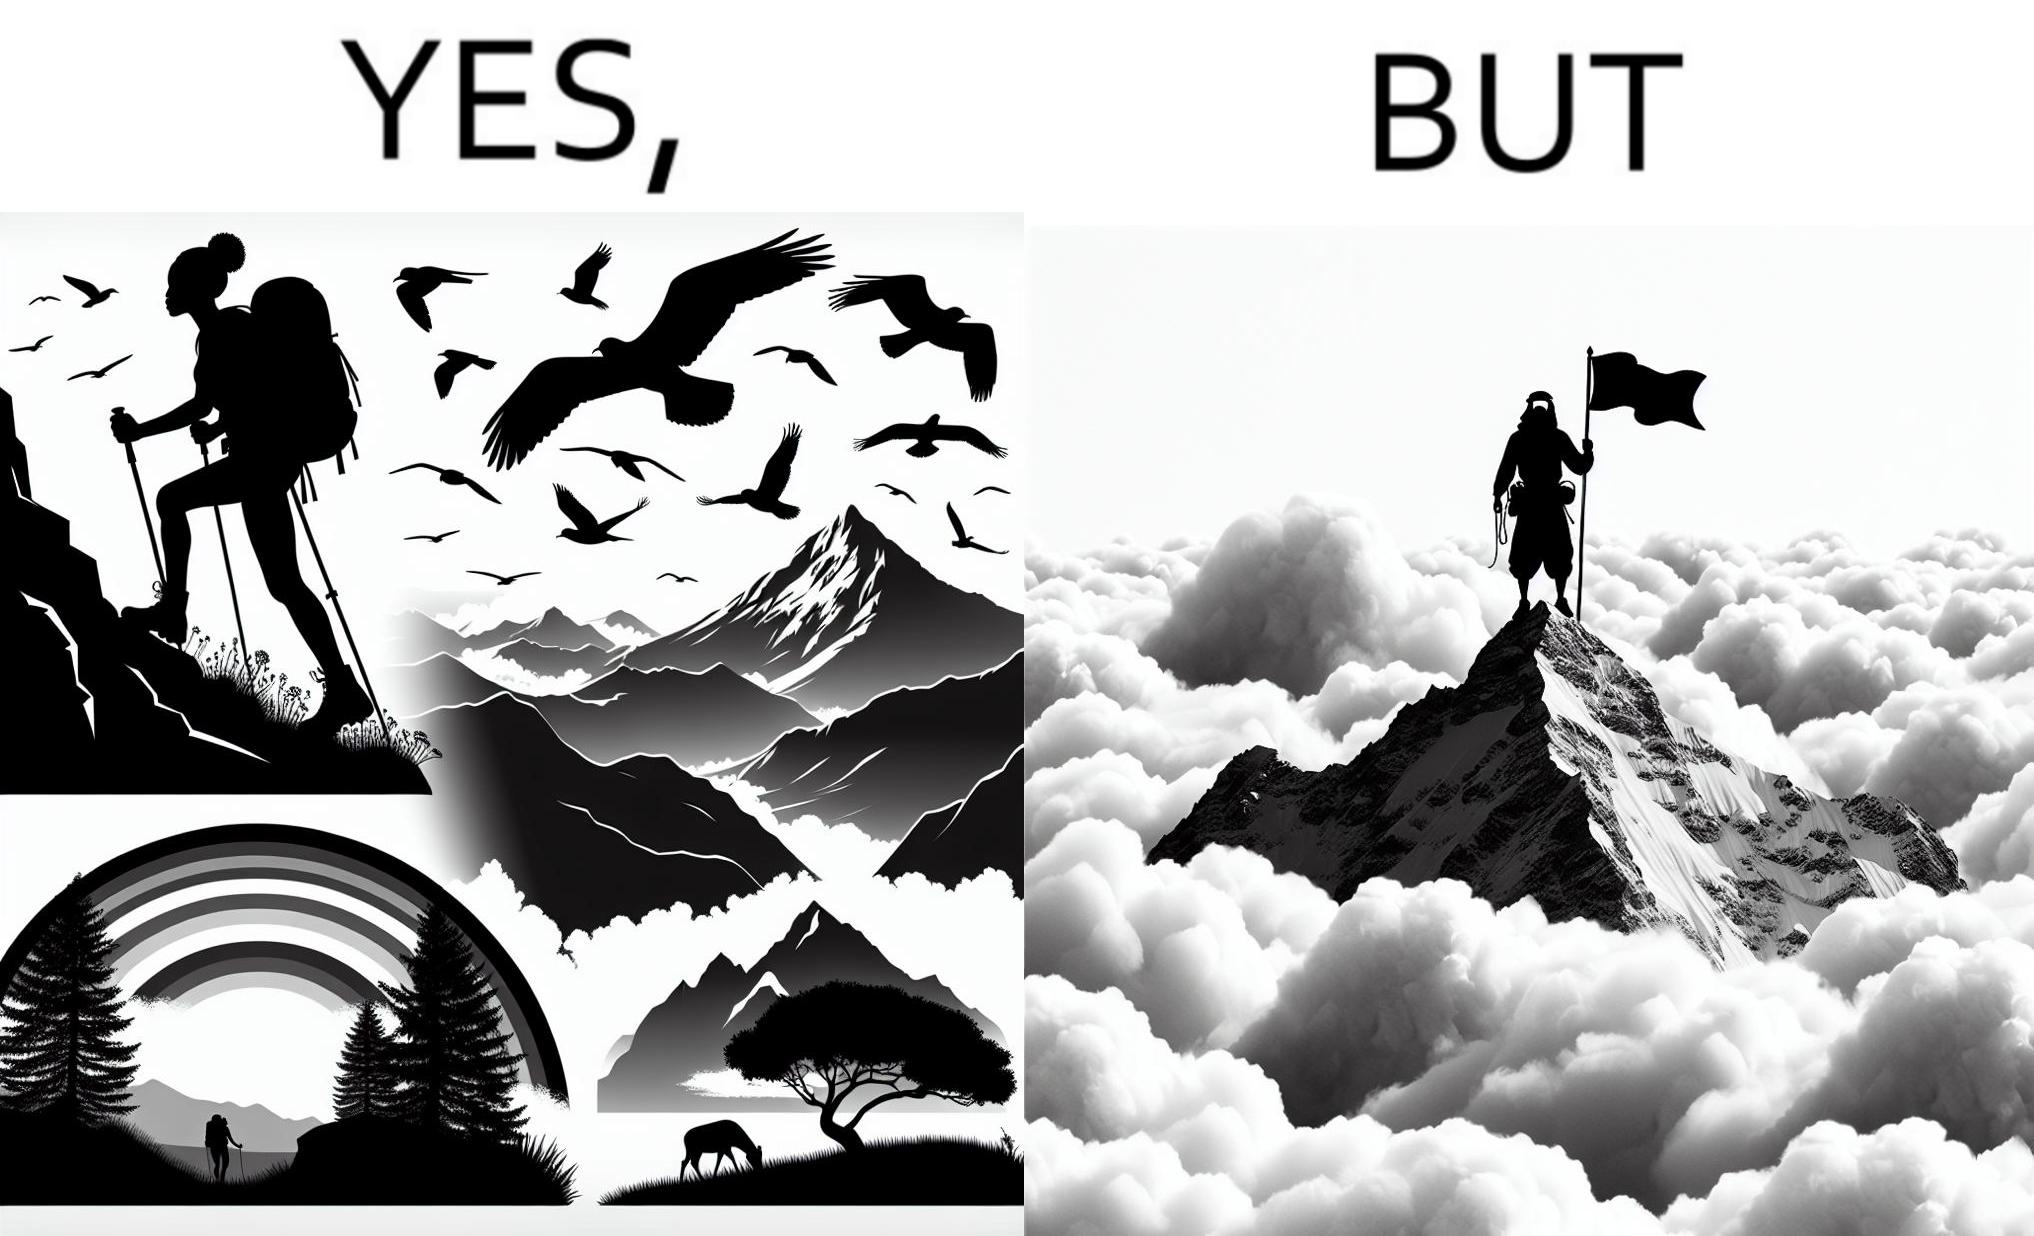Does this image contain satire or humor? Yes, this image is satirical. 